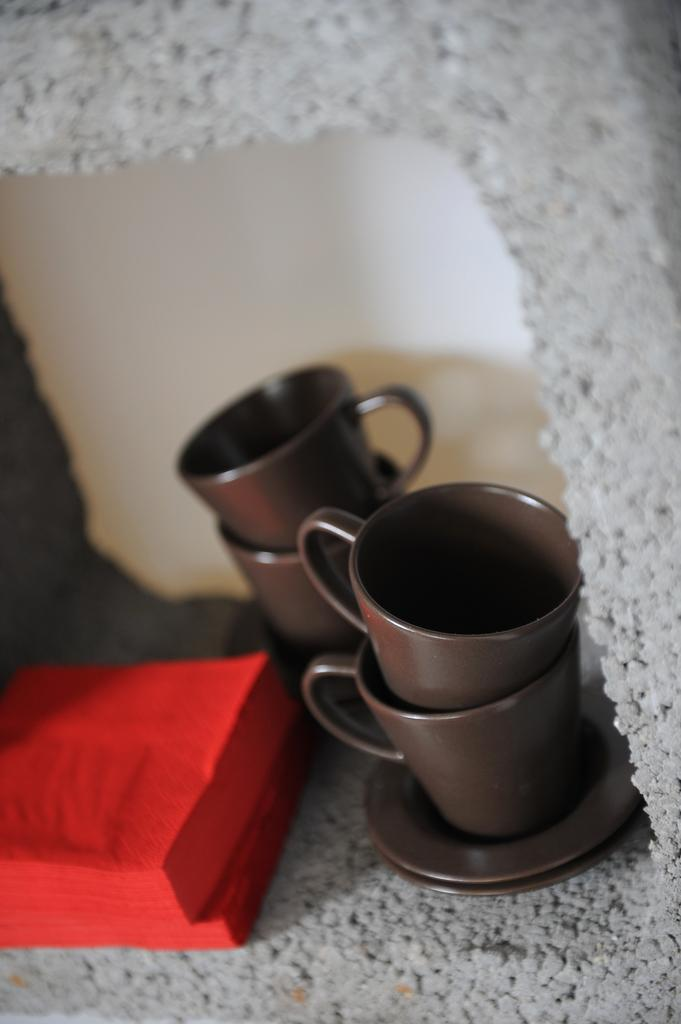What type of dishware is present in the image? There are cups and saucers in the image. Can you describe the white object in the image? There is a white object in the image, but its specific nature is not clear from the provided facts. What type of approval is being given by the salt in the image? There is no salt present in the image, so it cannot be giving any approval. 